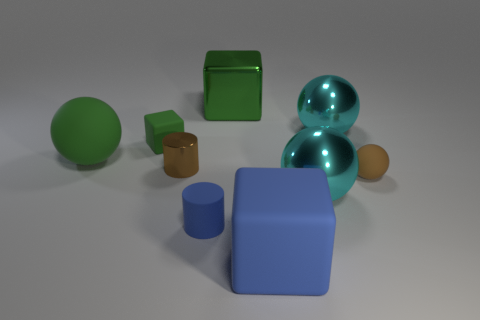What is the shape of the matte thing that is the same color as the tiny metallic object?
Provide a short and direct response. Sphere. Is the tiny sphere made of the same material as the large block that is to the left of the large blue matte block?
Offer a very short reply. No. How many cyan objects are to the left of the metallic sphere that is on the right side of the cyan ball that is in front of the brown ball?
Your answer should be very brief. 1. How many blue things are cylinders or small matte spheres?
Provide a short and direct response. 1. There is a small matte object that is behind the big green sphere; what shape is it?
Offer a terse response. Cube. What color is the matte cylinder that is the same size as the green matte block?
Your response must be concise. Blue. There is a small green rubber thing; is its shape the same as the green object on the right side of the blue matte cylinder?
Offer a terse response. Yes. There is a green object right of the shiny thing that is to the left of the blue object that is behind the large blue rubber thing; what is it made of?
Offer a terse response. Metal. How many big objects are either green rubber things or metallic things?
Keep it short and to the point. 4. How many other objects are the same size as the brown metallic thing?
Your answer should be compact. 3. 